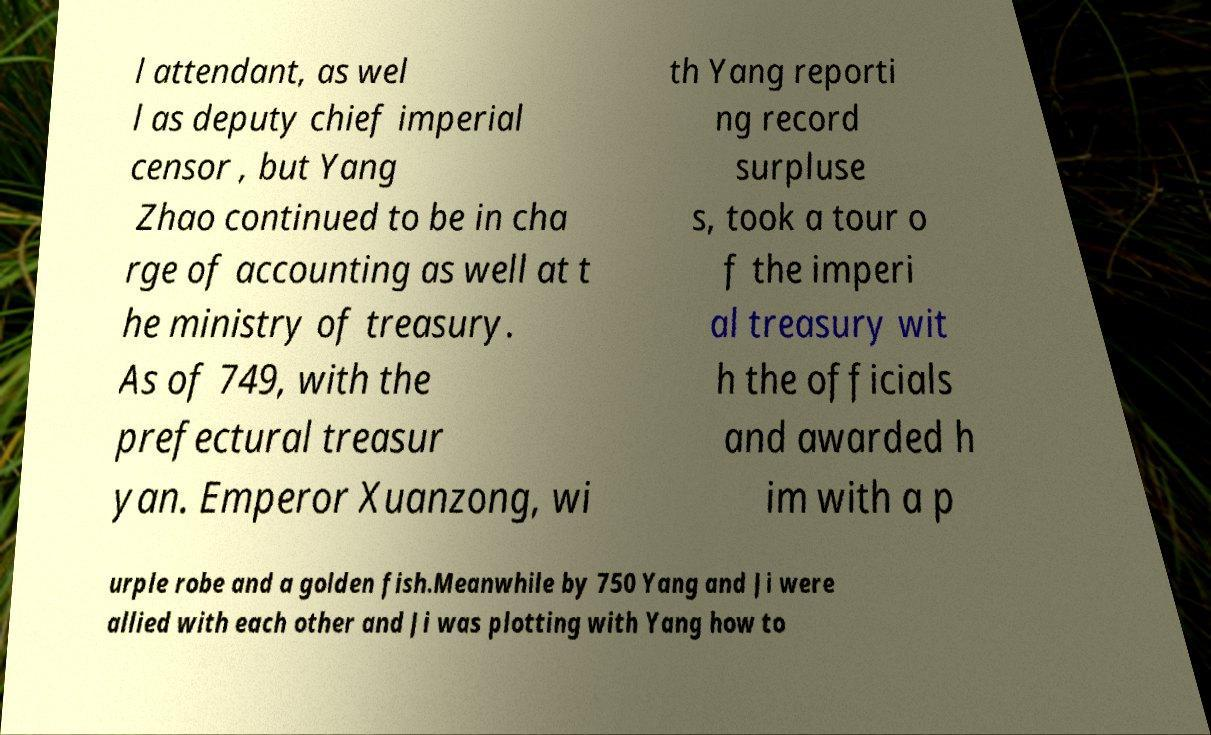I need the written content from this picture converted into text. Can you do that? l attendant, as wel l as deputy chief imperial censor , but Yang Zhao continued to be in cha rge of accounting as well at t he ministry of treasury. As of 749, with the prefectural treasur yan. Emperor Xuanzong, wi th Yang reporti ng record surpluse s, took a tour o f the imperi al treasury wit h the officials and awarded h im with a p urple robe and a golden fish.Meanwhile by 750 Yang and Ji were allied with each other and Ji was plotting with Yang how to 